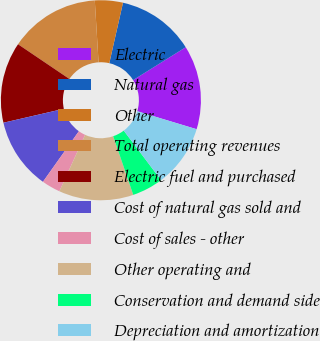Convert chart to OTSL. <chart><loc_0><loc_0><loc_500><loc_500><pie_chart><fcel>Electric<fcel>Natural gas<fcel>Other<fcel>Total operating revenues<fcel>Electric fuel and purchased<fcel>Cost of natural gas sold and<fcel>Cost of sales - other<fcel>Other operating and<fcel>Conservation and demand side<fcel>Depreciation and amortization<nl><fcel>13.57%<fcel>12.56%<fcel>4.52%<fcel>14.57%<fcel>13.07%<fcel>11.56%<fcel>3.02%<fcel>12.06%<fcel>5.03%<fcel>10.05%<nl></chart> 